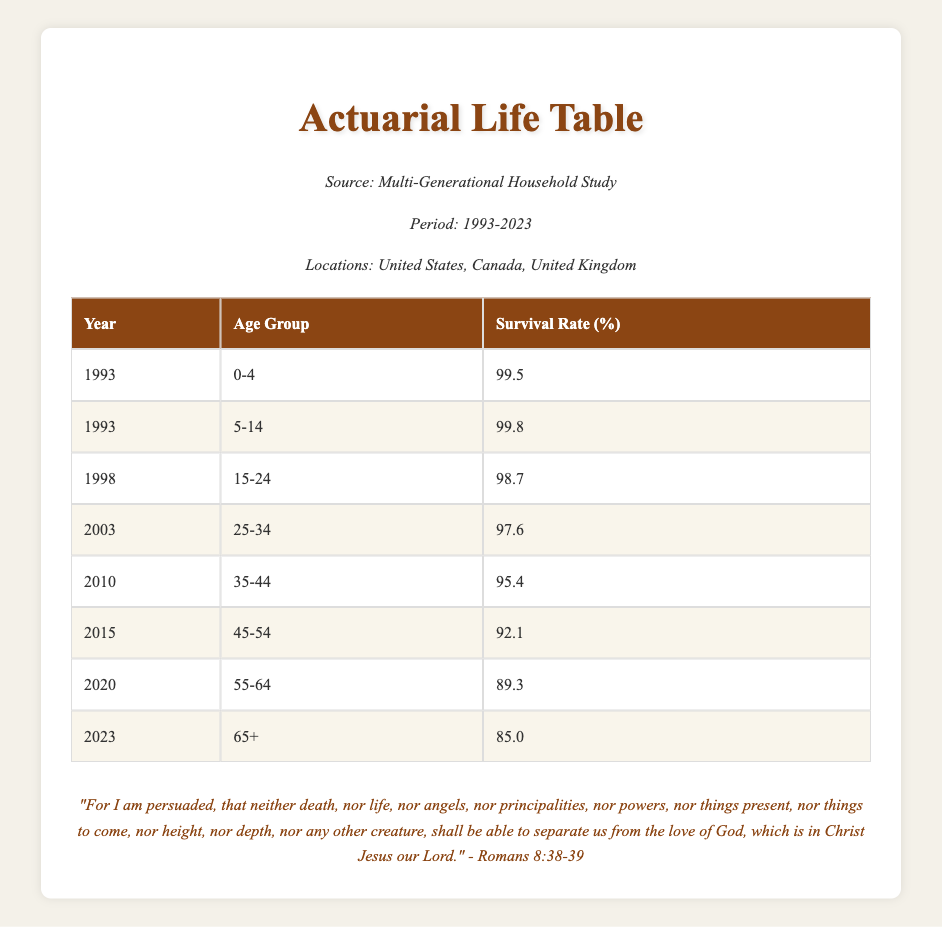What was the survival rate for the age group 65+ in 2023? The table shows that in the year 2023, the survival rate for the age group 65+ is listed as 85.0.
Answer: 85.0 What was the survival rate for the age group 0-4 in 1993? According to the table, the survival rate for the age group 0-4 in 1993 is shown as 99.5.
Answer: 99.5 What is the difference in survival rates between the age groups 45-54 and 55-64 in 2020? For the age group 45-54, the survival rate is 92.1, and for 55-64, it is 89.3. The difference is 92.1 - 89.3 = 2.8.
Answer: 2.8 Was the survival rate for the age group 15-24 higher in 1998 than for the age group 25-34 in 2003? The survival rate for the age group 15-24 in 1998 is 98.7, and for 25-34 in 2003, it is 97.6. Since 98.7 is greater than 97.6, the statement is true.
Answer: Yes What was the average survival rate for all age groups listed in the year 2010? The survival rate for the age group 35-44 in 2010 is 95.4. As this is the only rate listed for that year, the average is 95.4.
Answer: 95.4 What is the trend of survival rates from 1993 to 2023? By examining the table, we can see that survival rates generally decrease as the age groups increase over the years. This observation suggests a downward trend in survival rates for older age groups over time.
Answer: Decreasing trend Which age group had the highest survival rate in 1993? By looking at the table, we see that the age group 5-14 had the highest survival rate in 1993 at 99.8.
Answer: 5-14 Is it true that every age group's survival rate has decreased by 10% or more from their highest recorded value? Examining the data shows that while there are decreases in survival rates for older age groups, not every group shows a decrease of 10% or more. Therefore, this statement is false.
Answer: No What was the survival rate for the age group 35-44 in 2010 compared to the survival rate for the age group 65+ in 2023? The survival rate for 35-44 in 2010 is 95.4, and for 65+ in 2023 it is 85.0. The first rate is higher by 10.4. Thus, 35-44's rate is greater than that of the 65+ group.
Answer: 95.4 vs 85.0 